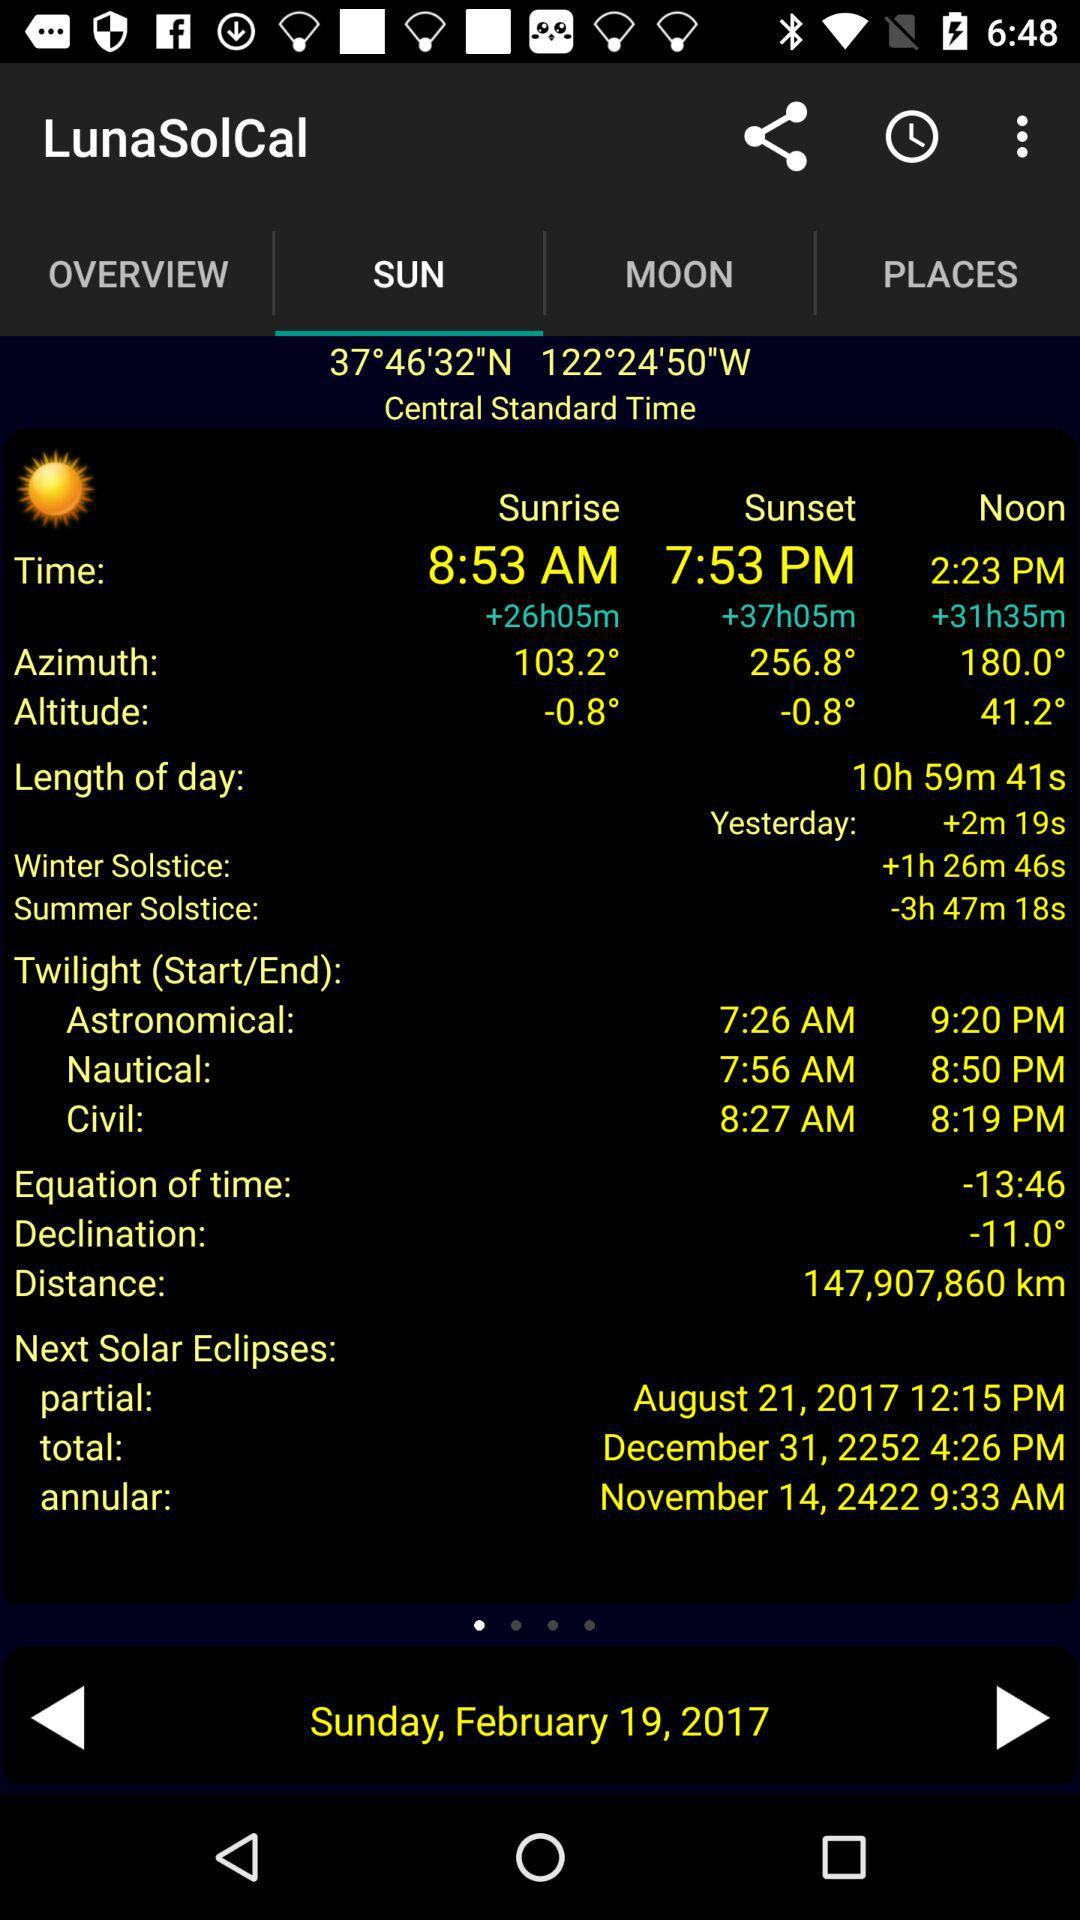What is the day on February 19? The day on February 19 is Sunday. 